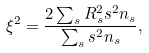<formula> <loc_0><loc_0><loc_500><loc_500>\xi ^ { 2 } = \frac { 2 \sum _ { s } R _ { s } ^ { 2 } s ^ { 2 } n _ { s } } { \sum _ { s } s ^ { 2 } n _ { s } } ,</formula> 